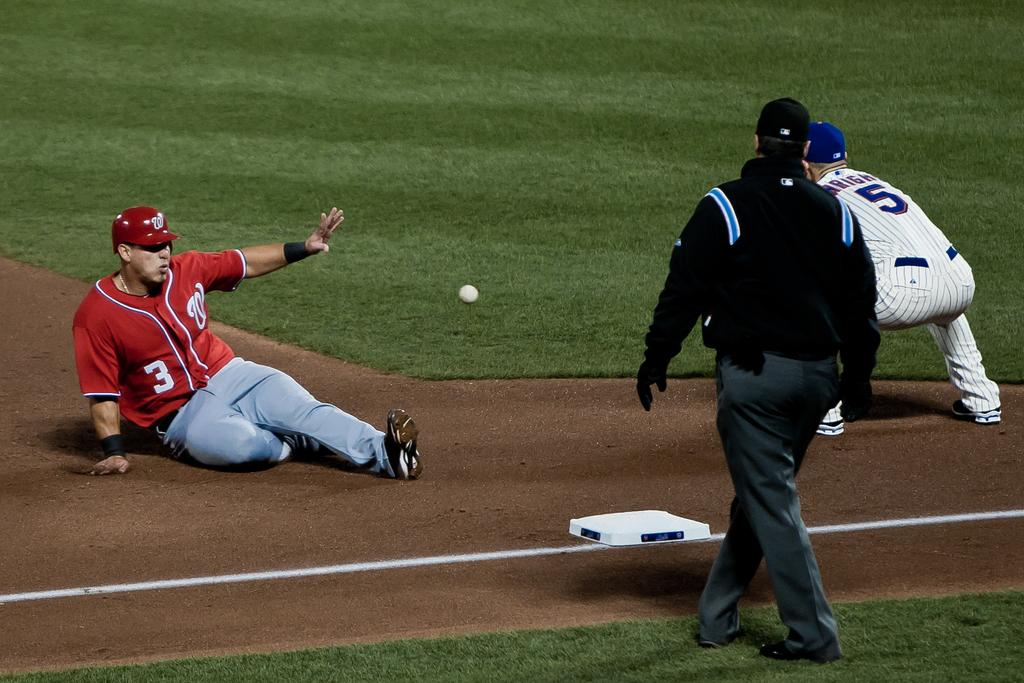Provide a one-sentence caption for the provided image. Baseball player #3 sliding into first base while #5 is trying to tag him out. 